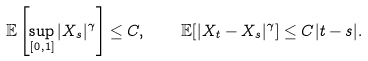<formula> <loc_0><loc_0><loc_500><loc_500>\mathbb { E } \left [ \sup _ { [ 0 , 1 ] } | X _ { s } | ^ { \gamma } \right ] \leq C , \quad \mathbb { E } [ | X _ { t } - X _ { s } | ^ { \gamma } ] \leq C | t - s | .</formula> 